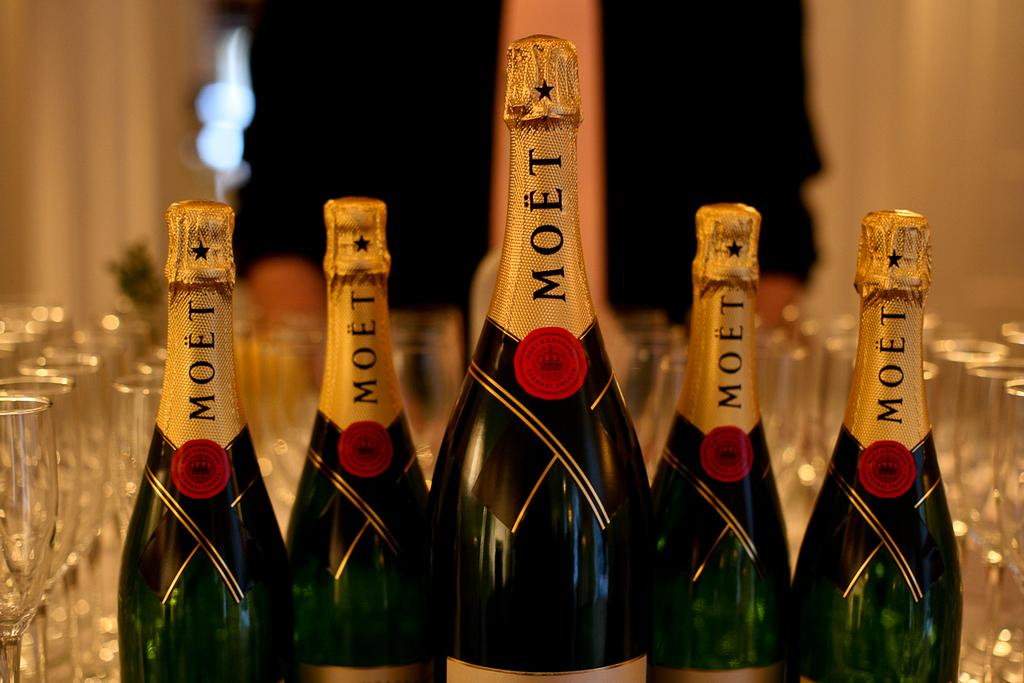<image>
Create a compact narrative representing the image presented. Bottles of unopened wine made by the MOET company. 